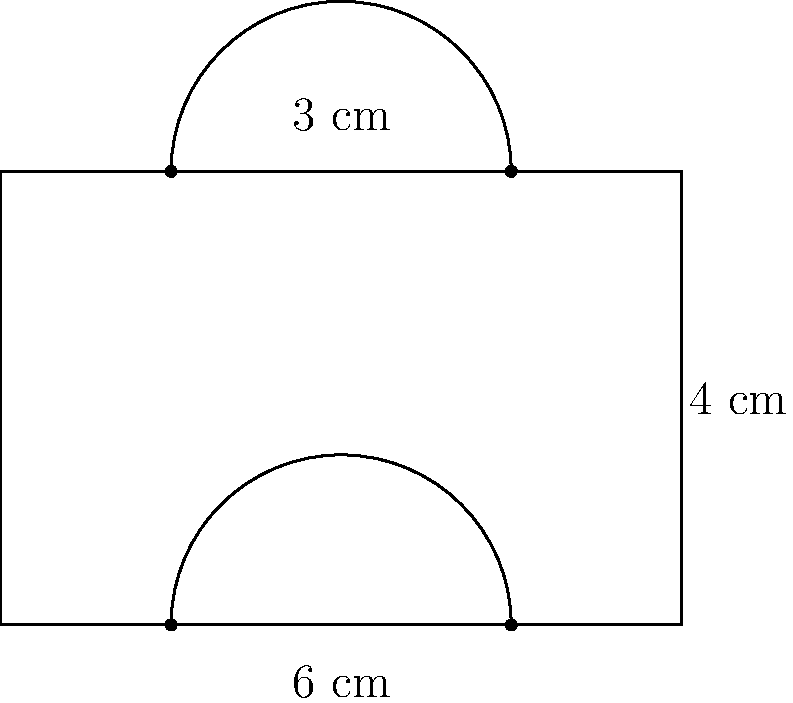Consider the composite shape shown in the figure above. It consists of a rectangle with two semicircles attached to its top and bottom sides. The width of the rectangle is 6 cm, and its height is 4 cm. The diameter of each semicircle is 3 cm. Calculate the total area of this composite shape. To find the total area, we need to calculate the areas of the rectangle and both semicircles separately, then add them together.

1. Area of the rectangle:
   $A_{rectangle} = length \times width = 6 \text{ cm} \times 4 \text{ cm} = 24 \text{ cm}^2$

2. Area of one semicircle:
   $A_{semicircle} = \frac{1}{2} \times \pi r^2$
   where $r$ is the radius of the semicircle.
   $r = \frac{3 \text{ cm}}{2} = 1.5 \text{ cm}$
   $A_{semicircle} = \frac{1}{2} \times \pi \times (1.5 \text{ cm})^2 = \frac{9\pi}{8} \text{ cm}^2$

3. Total area of both semicircles:
   $A_{both semicircles} = 2 \times \frac{9\pi}{8} \text{ cm}^2 = \frac{9\pi}{4} \text{ cm}^2$

4. Total area of the composite shape:
   $A_{total} = A_{rectangle} + A_{both semicircles}$
   $A_{total} = 24 \text{ cm}^2 + \frac{9\pi}{4} \text{ cm}^2$
   $A_{total} = 24 + \frac{9\pi}{4} \text{ cm}^2$

5. Simplifying the final answer:
   $A_{total} = (24 + \frac{9\pi}{4}) \text{ cm}^2 \approx 31.06 \text{ cm}^2$
Answer: $(24 + \frac{9\pi}{4}) \text{ cm}^2$ or approximately $31.06 \text{ cm}^2$ 